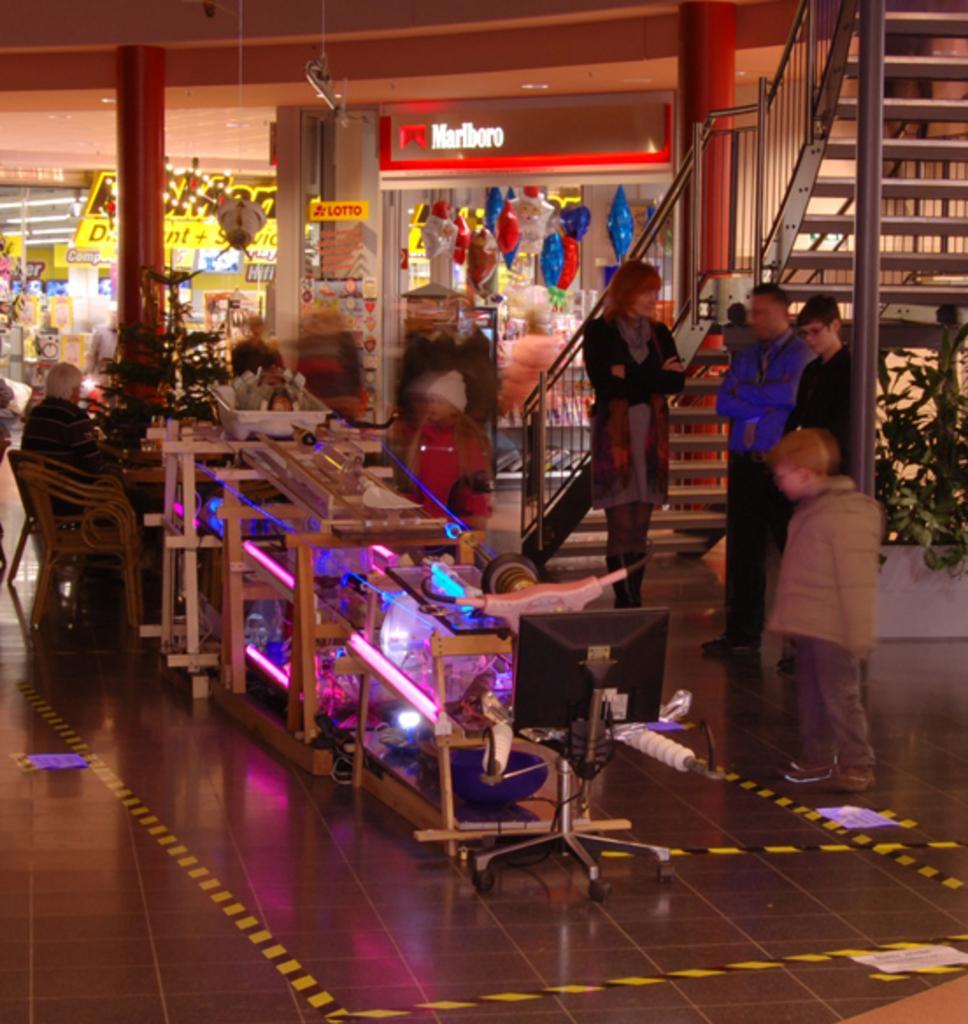Please provide a concise description of this image. In this picture I can see group of people standing, there are stairs, lights, shops, boards, plants, chairs and there are some objects. 